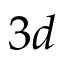Convert formula to latex. <formula><loc_0><loc_0><loc_500><loc_500>3 d</formula> 